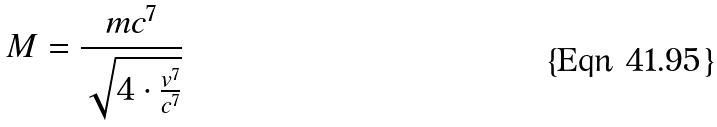<formula> <loc_0><loc_0><loc_500><loc_500>M = \frac { m c ^ { 7 } } { \sqrt { 4 \cdot \frac { v ^ { 7 } } { c ^ { 7 } } } }</formula> 